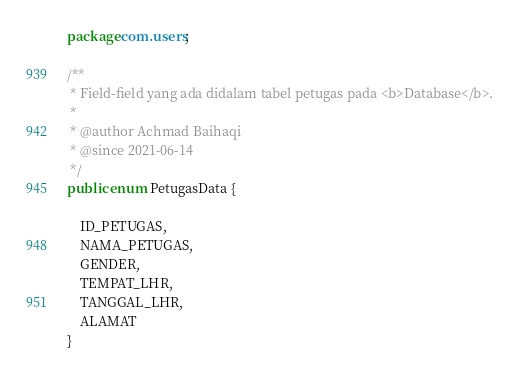<code> <loc_0><loc_0><loc_500><loc_500><_Java_>package com.users;

/**
 * Field-field yang ada didalam tabel petugas pada <b>Database</b>.
 *
 * @author Achmad Baihaqi
 * @since 2021-06-14
 */
public enum PetugasData {
    
    ID_PETUGAS,
    NAMA_PETUGAS,
    GENDER,
    TEMPAT_LHR,
    TANGGAL_LHR,
    ALAMAT
}
</code> 